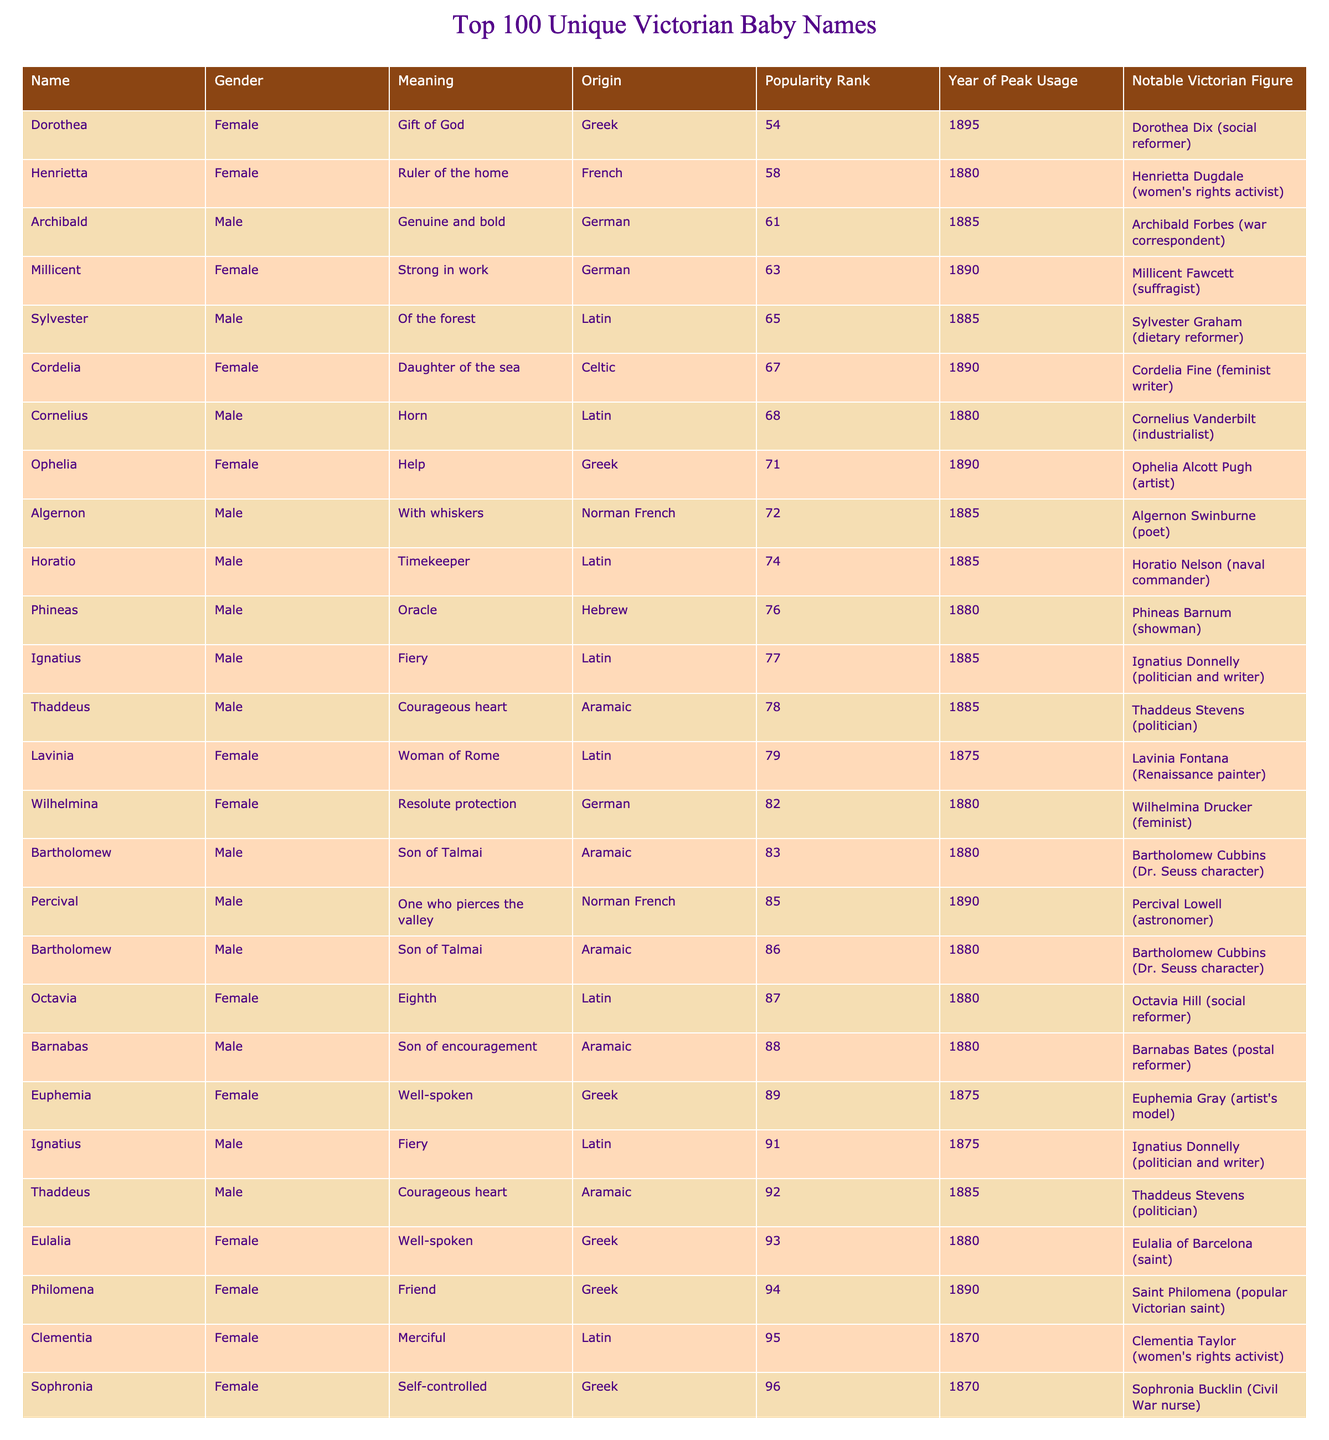What is the meaning of the name Octavia? According to the table, the meaning of Octavia is "Eighth" and it is derived from Latin.
Answer: Eighth Who is a notable Victorian figure associated with the name Euphemia? The table lists Euphemia Gray as a notable Victorian figure associated with the name Euphemia.
Answer: Euphemia Gray What gender is the name Millicent? The table indicates that Millicent is a female name.
Answer: Female Which name has the highest popularity rank in this table? The name Araminta has the lowest popularity rank at 99, indicating it is the least popular in the table.
Answer: Araminta What is the origin of the name Thaddeus? The table shows that Thaddeus is of Aramaic origin.
Answer: Aramaic True or false: The name Philomena means "Friend." Yes, the table confirms that the meaning of Philomena is "Friend."
Answer: True Which two names have the same origin and what is that origin? The names Bartholomew and Thaddeus both have an Aramaic origin according to the table.
Answer: Aramaic What is the average popularity rank of male names in the table? Calculating the popularity ranks for male names: 92, 98, 76, 68, 72, 85, 74, 61, 91, 78, 88, 86, 77 gives us a total of 1023. There are 13 male names, so the average is 1023/13 = 78.69.
Answer: 78.69 Which name correlates with the notable figure Clementia Taylor? According to the table, Clementia Taylor is associated with the name Clementia.
Answer: Clementia What is the meaning of the name Cordelia? The table states that Cordelia means "Daughter of the sea."
Answer: Daughter of the sea Identify a name that has a peak usage rank in the year 1890. The name Millicent peaked in popularity in 1890 as per the table.
Answer: Millicent Which name means "Self-controlled" and what is its gender? The name Sophronia means "Self-controlled," and it is a female name according to the table.
Answer: Sophronia, Female 